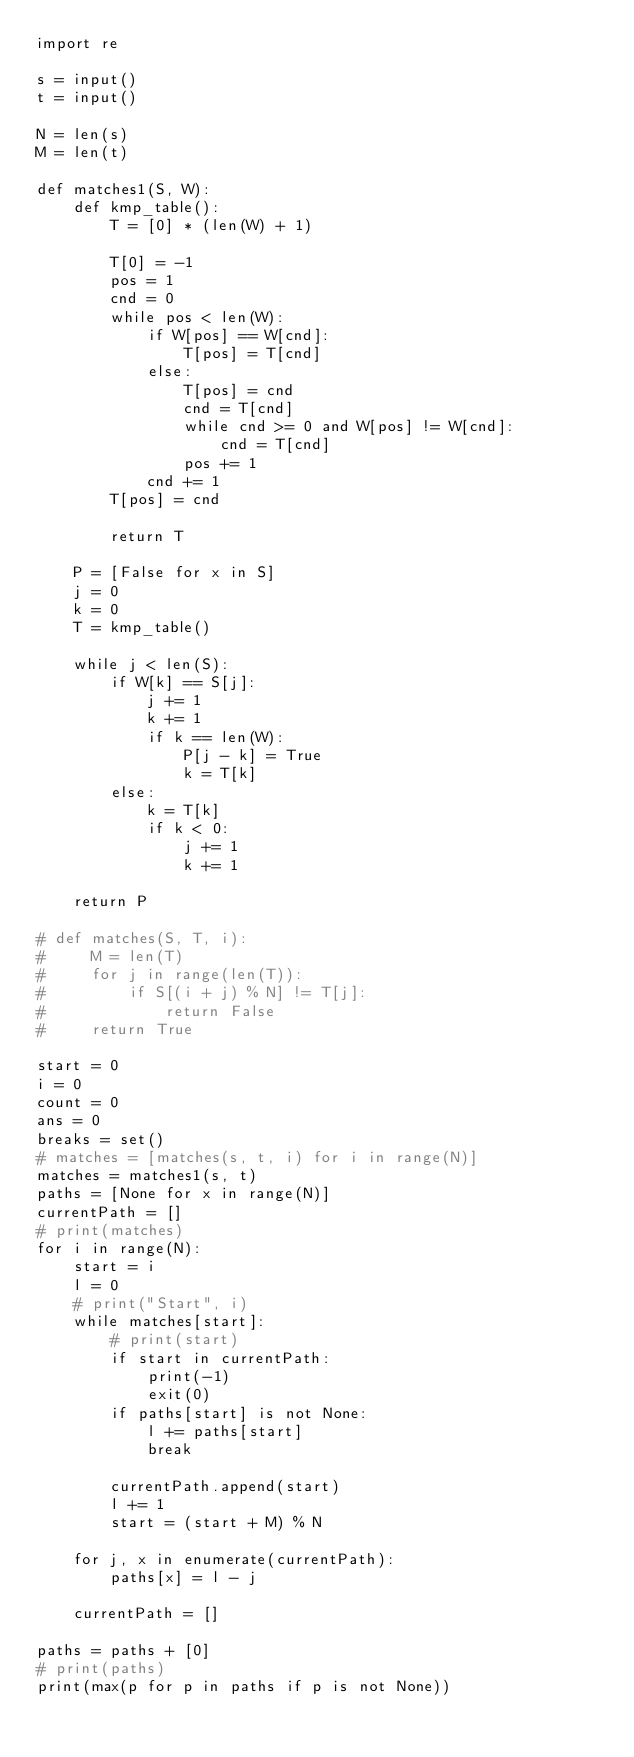Convert code to text. <code><loc_0><loc_0><loc_500><loc_500><_Python_>import re

s = input()
t = input()

N = len(s)
M = len(t)

def matches1(S, W):
    def kmp_table():
        T = [0] * (len(W) + 1)

        T[0] = -1
        pos = 1
        cnd = 0
        while pos < len(W):
            if W[pos] == W[cnd]:
                T[pos] = T[cnd]
            else:
                T[pos] = cnd
                cnd = T[cnd]
                while cnd >= 0 and W[pos] != W[cnd]:
                    cnd = T[cnd]
                pos += 1
            cnd += 1
        T[pos] = cnd

        return T

    P = [False for x in S]
    j = 0
    k = 0
    T = kmp_table()

    while j < len(S):
        if W[k] == S[j]:
            j += 1
            k += 1
            if k == len(W):
                P[j - k] = True
                k = T[k]
        else:
            k = T[k]
            if k < 0:
                j += 1
                k += 1

    return P

# def matches(S, T, i):
#     M = len(T)
#     for j in range(len(T)):
#         if S[(i + j) % N] != T[j]:
#             return False
#     return True

start = 0
i = 0
count = 0
ans = 0
breaks = set()
# matches = [matches(s, t, i) for i in range(N)]
matches = matches1(s, t)
paths = [None for x in range(N)]
currentPath = []
# print(matches)
for i in range(N):
    start = i
    l = 0
    # print("Start", i)
    while matches[start]:
        # print(start)
        if start in currentPath:
            print(-1)
            exit(0)
        if paths[start] is not None:
            l += paths[start]
            break

        currentPath.append(start)
        l += 1
        start = (start + M) % N

    for j, x in enumerate(currentPath):
        paths[x] = l - j

    currentPath = []

paths = paths + [0]
# print(paths)
print(max(p for p in paths if p is not None))
</code> 